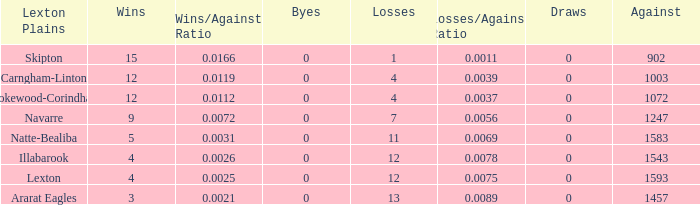What is the most wins with 0 byes? None. 